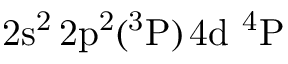Convert formula to latex. <formula><loc_0><loc_0><loc_500><loc_500>2 s ^ { 2 } \, 2 p ^ { 2 } ( ^ { 3 } P ) \, 4 d ^ { 4 } P</formula> 